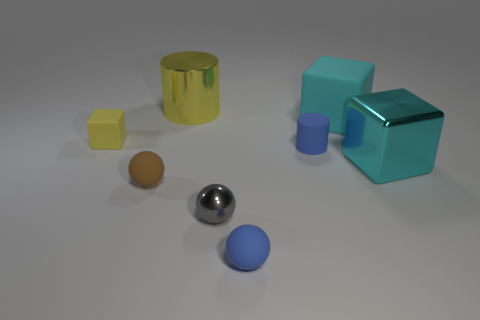What shape is the object that is the same color as the metallic cylinder?
Make the answer very short. Cube. Is there another cyan shiny thing of the same shape as the cyan metal thing?
Offer a very short reply. No. Are there the same number of yellow metallic cylinders that are right of the big yellow metallic cylinder and cylinders to the left of the tiny brown object?
Offer a terse response. Yes. Is there any other thing that has the same size as the blue rubber cylinder?
Give a very brief answer. Yes. How many purple objects are big spheres or small things?
Make the answer very short. 0. What number of brown matte spheres have the same size as the blue rubber cylinder?
Make the answer very short. 1. What color is the block that is both on the right side of the tiny gray metal sphere and left of the cyan shiny block?
Give a very brief answer. Cyan. Is the number of big metal things behind the big cyan rubber thing greater than the number of small green rubber spheres?
Make the answer very short. Yes. Is there a blue ball?
Offer a terse response. Yes. Is the color of the small metallic object the same as the large shiny cube?
Give a very brief answer. No. 